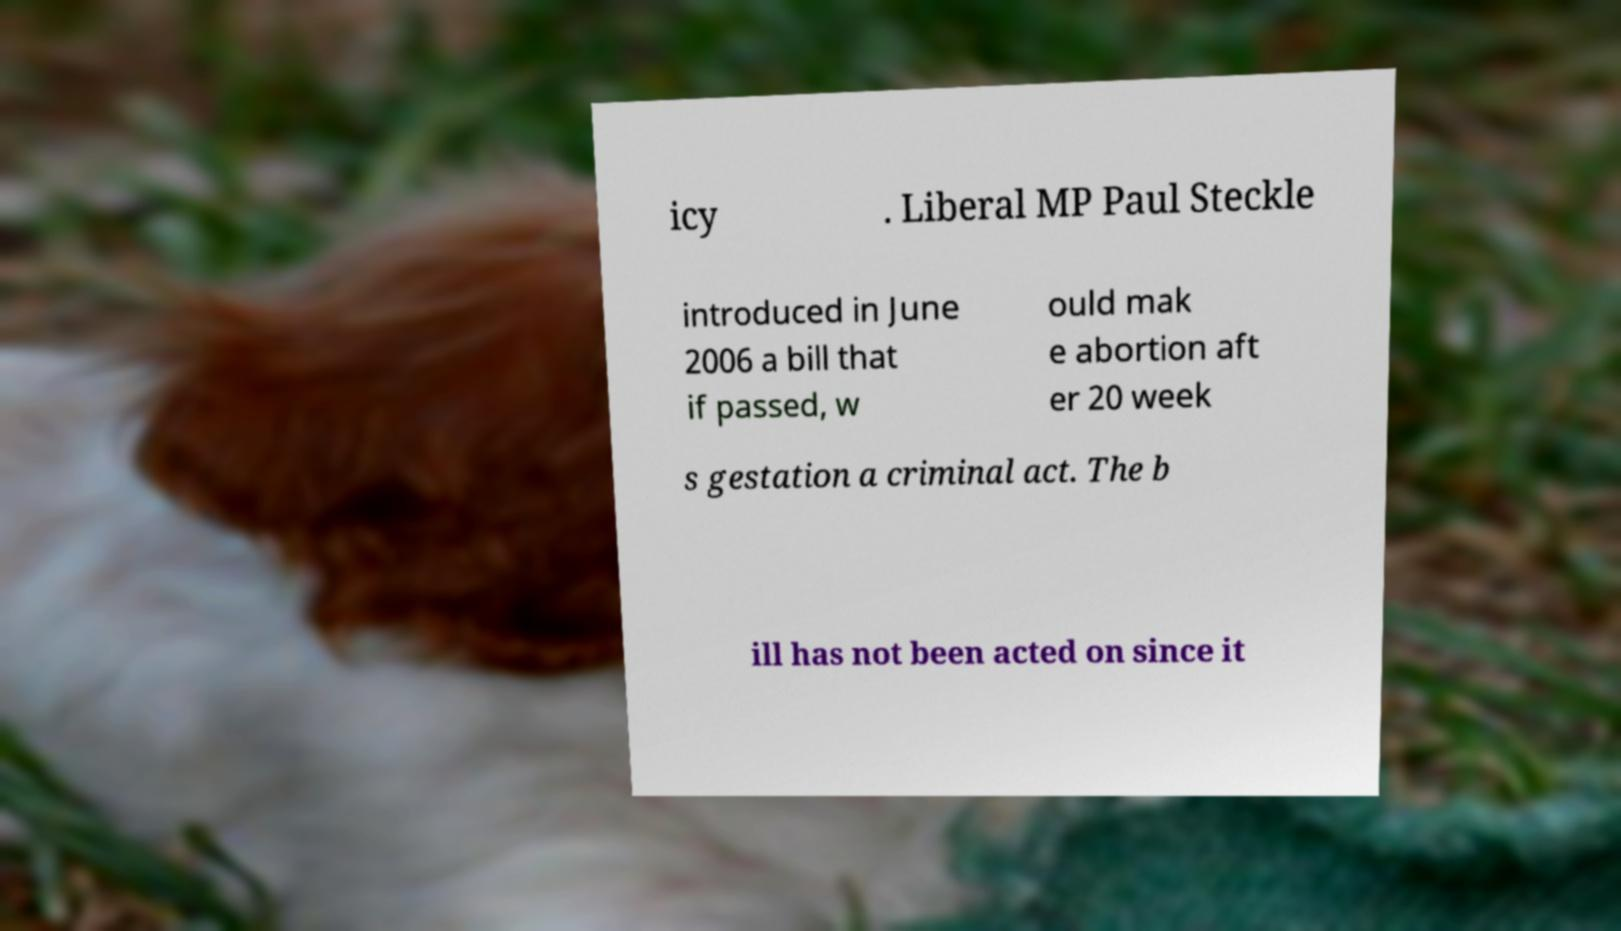Can you read and provide the text displayed in the image?This photo seems to have some interesting text. Can you extract and type it out for me? icy . Liberal MP Paul Steckle introduced in June 2006 a bill that if passed, w ould mak e abortion aft er 20 week s gestation a criminal act. The b ill has not been acted on since it 